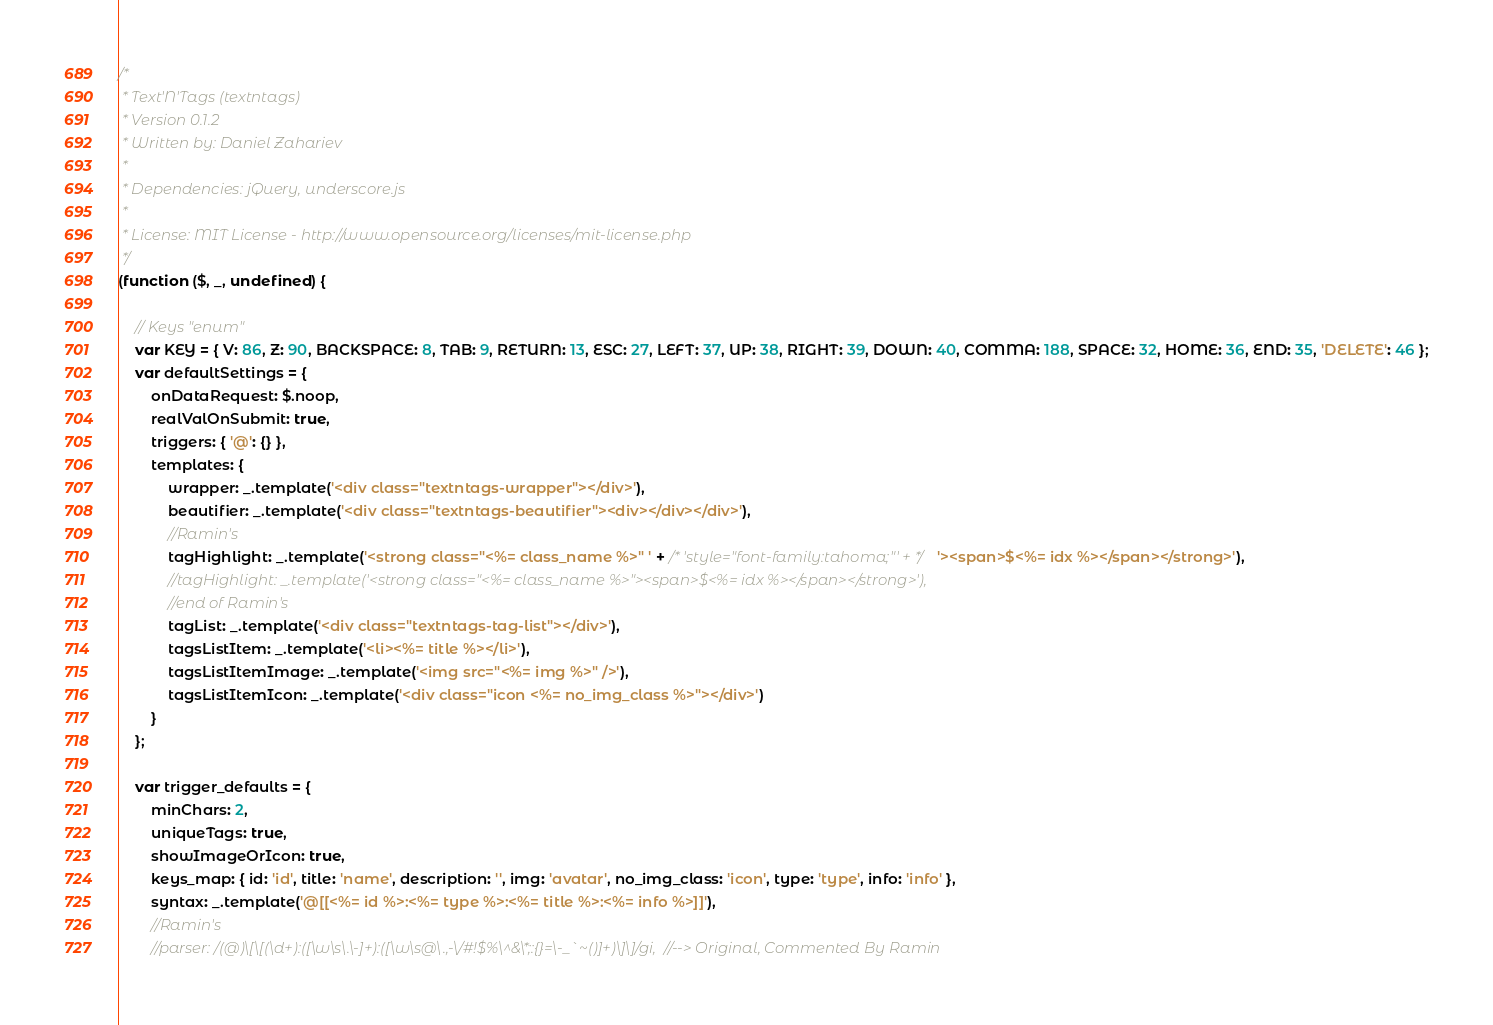<code> <loc_0><loc_0><loc_500><loc_500><_JavaScript_>/*
 * Text'N'Tags (textntags)
 * Version 0.1.2
 * Written by: Daniel Zahariev
 *
 * Dependencies: jQuery, underscore.js
 *
 * License: MIT License - http://www.opensource.org/licenses/mit-license.php
 */
(function ($, _, undefined) {

    // Keys "enum"
    var KEY = { V: 86, Z: 90, BACKSPACE: 8, TAB: 9, RETURN: 13, ESC: 27, LEFT: 37, UP: 38, RIGHT: 39, DOWN: 40, COMMA: 188, SPACE: 32, HOME: 36, END: 35, 'DELETE': 46 };
    var defaultSettings = {
        onDataRequest: $.noop,
        realValOnSubmit: true,
        triggers: { '@': {} },
        templates: {
            wrapper: _.template('<div class="textntags-wrapper"></div>'),
            beautifier: _.template('<div class="textntags-beautifier"><div></div></div>'),
            //Ramin's
            tagHighlight: _.template('<strong class="<%= class_name %>" ' + /* 'style="font-family:tahoma;"' + */'><span>$<%= idx %></span></strong>'),
            //tagHighlight: _.template('<strong class="<%= class_name %>"><span>$<%= idx %></span></strong>'),
            //end of Ramin's
            tagList: _.template('<div class="textntags-tag-list"></div>'),
            tagsListItem: _.template('<li><%= title %></li>'),
            tagsListItemImage: _.template('<img src="<%= img %>" />'),
            tagsListItemIcon: _.template('<div class="icon <%= no_img_class %>"></div>')
        }
    };

    var trigger_defaults = {
        minChars: 2,
        uniqueTags: true,
        showImageOrIcon: true,
        keys_map: { id: 'id', title: 'name', description: '', img: 'avatar', no_img_class: 'icon', type: 'type', info: 'info' },
        syntax: _.template('@[[<%= id %>:<%= type %>:<%= title %>:<%= info %>]]'),
        //Ramin's
        //parser: /(@)\[\[(\d+):([\w\s\.\-]+):([\w\s@\.,-\/#!$%\^&\*;:{}=\-_`~()]+)\]\]/gi,  //--> Original, Commented By Ramin</code> 